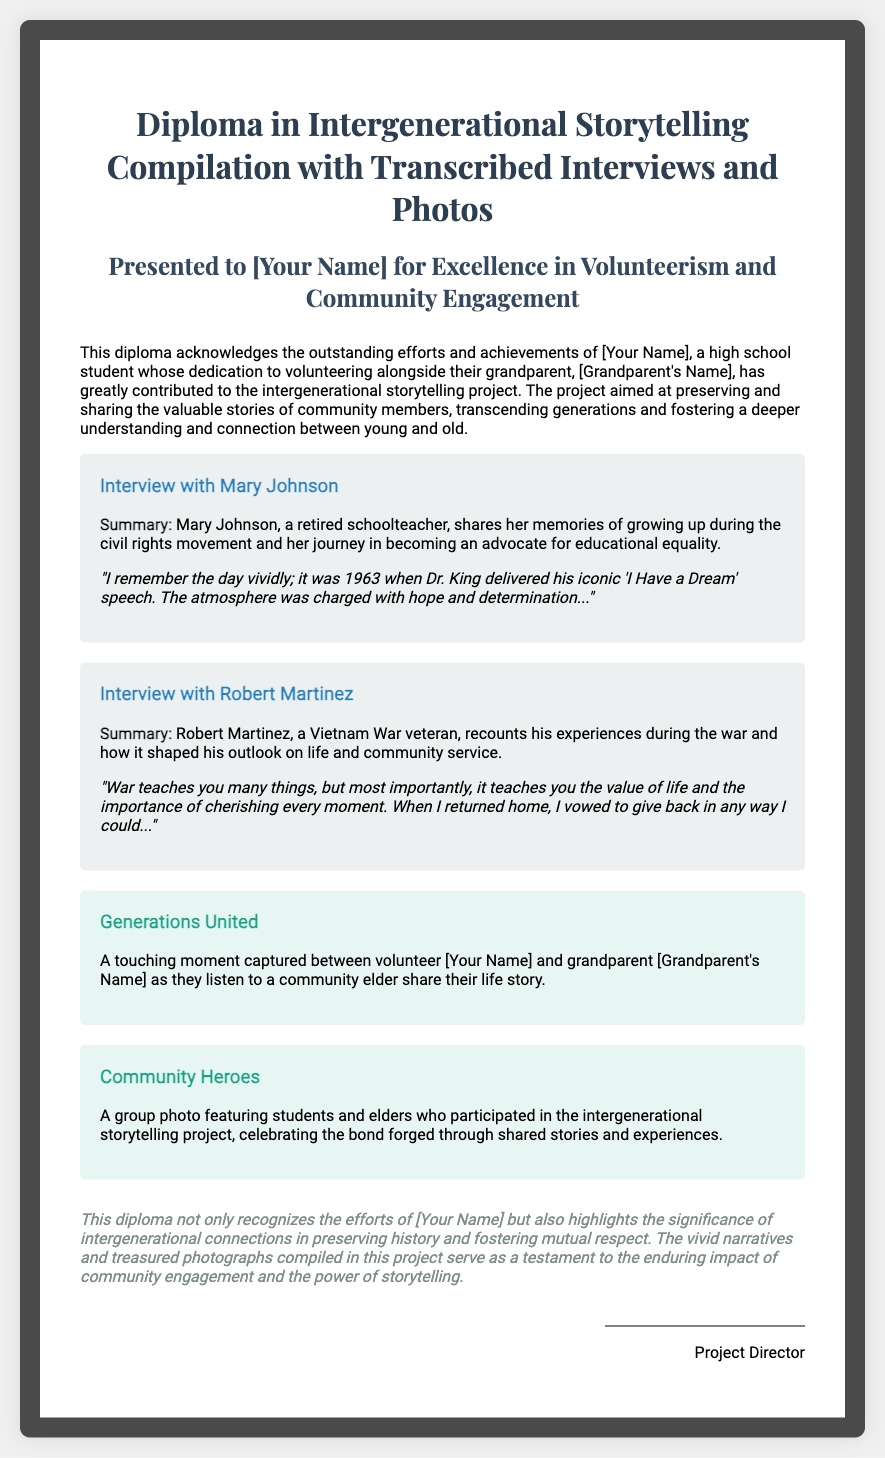What is the title of the diploma? The title of the diploma is stated at the top of the document, which is "Diploma in Intergenerational Storytelling Compilation with Transcribed Interviews and Photos."
Answer: Diploma in Intergenerational Storytelling Compilation with Transcribed Interviews and Photos Who is the diploma presented to? The diploma is presented to a high school student named [Your Name].
Answer: [Your Name] What is the name of the first interviewee? The first interviewee mentioned in the document is Mary Johnson.
Answer: Mary Johnson What year was Dr. King's "I Have a Dream" speech delivered? The document mentions that Dr. King's speech was delivered in 1963.
Answer: 1963 What is the main theme of the storytelling project? The main theme of the project is to preserve and share valuable stories from community members.
Answer: Preserving and sharing valuable stories Which community member shared their experiences during the Vietnam War? Robert Martinez is the community member who shared his experiences during the Vietnam War.
Answer: Robert Martinez What is the title of the first photo described in the document? The title of the first photo is "Generations United."
Answer: Generations United What does this diploma highlight about intergenerational connections? The diploma highlights that intergenerational connections are significant in preserving history and fostering mutual respect.
Answer: Preserving history and fostering mutual respect What is the professional role of the person signing the diploma? The professional role of the person signing the diploma is the Project Director.
Answer: Project Director 